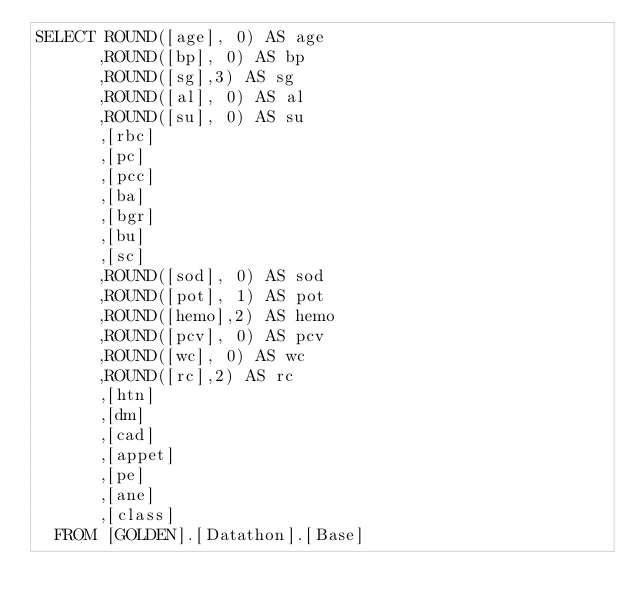Convert code to text. <code><loc_0><loc_0><loc_500><loc_500><_SQL_>SELECT ROUND([age], 0) AS age
      ,ROUND([bp], 0) AS bp
      ,ROUND([sg],3) AS sg
      ,ROUND([al], 0) AS al
      ,ROUND([su], 0) AS su
      ,[rbc]
      ,[pc]
      ,[pcc]
      ,[ba]
      ,[bgr]
      ,[bu]
      ,[sc]
      ,ROUND([sod], 0) AS sod
      ,ROUND([pot], 1) AS pot
      ,ROUND([hemo],2) AS hemo
      ,ROUND([pcv], 0) AS pcv
      ,ROUND([wc], 0) AS wc
      ,ROUND([rc],2) AS rc
      ,[htn]
      ,[dm]
      ,[cad]
      ,[appet]
      ,[pe]
      ,[ane]
      ,[class]
  FROM [GOLDEN].[Datathon].[Base]</code> 